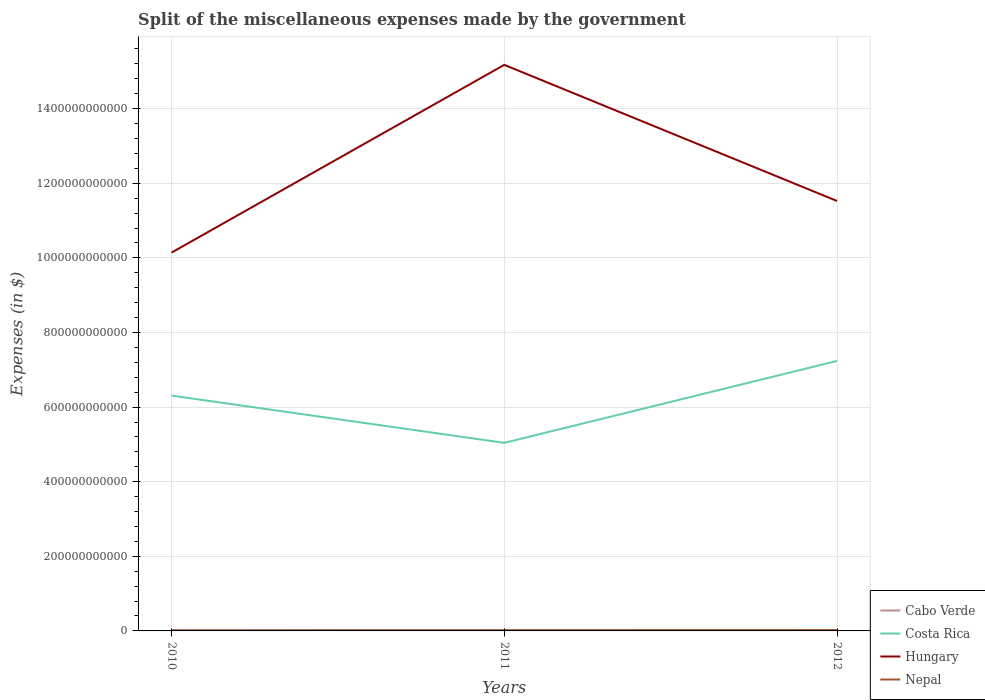Does the line corresponding to Hungary intersect with the line corresponding to Nepal?
Provide a succinct answer. No. Across all years, what is the maximum miscellaneous expenses made by the government in Nepal?
Give a very brief answer. 1.38e+09. In which year was the miscellaneous expenses made by the government in Hungary maximum?
Ensure brevity in your answer.  2010. What is the total miscellaneous expenses made by the government in Cabo Verde in the graph?
Ensure brevity in your answer.  8.47e+07. What is the difference between the highest and the second highest miscellaneous expenses made by the government in Nepal?
Offer a terse response. 6.13e+08. How many years are there in the graph?
Your answer should be very brief. 3. What is the difference between two consecutive major ticks on the Y-axis?
Keep it short and to the point. 2.00e+11. Where does the legend appear in the graph?
Offer a very short reply. Bottom right. How many legend labels are there?
Ensure brevity in your answer.  4. How are the legend labels stacked?
Your answer should be compact. Vertical. What is the title of the graph?
Your answer should be very brief. Split of the miscellaneous expenses made by the government. What is the label or title of the X-axis?
Your answer should be very brief. Years. What is the label or title of the Y-axis?
Ensure brevity in your answer.  Expenses (in $). What is the Expenses (in $) in Cabo Verde in 2010?
Make the answer very short. 1.46e+09. What is the Expenses (in $) in Costa Rica in 2010?
Your answer should be very brief. 6.31e+11. What is the Expenses (in $) in Hungary in 2010?
Your response must be concise. 1.01e+12. What is the Expenses (in $) of Nepal in 2010?
Offer a very short reply. 1.38e+09. What is the Expenses (in $) in Cabo Verde in 2011?
Offer a very short reply. 1.80e+09. What is the Expenses (in $) of Costa Rica in 2011?
Keep it short and to the point. 5.04e+11. What is the Expenses (in $) in Hungary in 2011?
Your answer should be compact. 1.52e+12. What is the Expenses (in $) of Nepal in 2011?
Your response must be concise. 1.86e+09. What is the Expenses (in $) of Cabo Verde in 2012?
Provide a succinct answer. 1.71e+09. What is the Expenses (in $) of Costa Rica in 2012?
Make the answer very short. 7.24e+11. What is the Expenses (in $) in Hungary in 2012?
Your response must be concise. 1.15e+12. What is the Expenses (in $) in Nepal in 2012?
Provide a succinct answer. 2.00e+09. Across all years, what is the maximum Expenses (in $) of Cabo Verde?
Offer a very short reply. 1.80e+09. Across all years, what is the maximum Expenses (in $) in Costa Rica?
Give a very brief answer. 7.24e+11. Across all years, what is the maximum Expenses (in $) in Hungary?
Provide a short and direct response. 1.52e+12. Across all years, what is the maximum Expenses (in $) in Nepal?
Keep it short and to the point. 2.00e+09. Across all years, what is the minimum Expenses (in $) of Cabo Verde?
Your answer should be very brief. 1.46e+09. Across all years, what is the minimum Expenses (in $) in Costa Rica?
Provide a short and direct response. 5.04e+11. Across all years, what is the minimum Expenses (in $) of Hungary?
Keep it short and to the point. 1.01e+12. Across all years, what is the minimum Expenses (in $) in Nepal?
Your response must be concise. 1.38e+09. What is the total Expenses (in $) of Cabo Verde in the graph?
Provide a succinct answer. 4.97e+09. What is the total Expenses (in $) of Costa Rica in the graph?
Your response must be concise. 1.86e+12. What is the total Expenses (in $) of Hungary in the graph?
Make the answer very short. 3.68e+12. What is the total Expenses (in $) in Nepal in the graph?
Give a very brief answer. 5.24e+09. What is the difference between the Expenses (in $) of Cabo Verde in 2010 and that in 2011?
Your response must be concise. -3.44e+08. What is the difference between the Expenses (in $) in Costa Rica in 2010 and that in 2011?
Ensure brevity in your answer.  1.27e+11. What is the difference between the Expenses (in $) of Hungary in 2010 and that in 2011?
Provide a succinct answer. -5.03e+11. What is the difference between the Expenses (in $) of Nepal in 2010 and that in 2011?
Provide a short and direct response. -4.77e+08. What is the difference between the Expenses (in $) in Cabo Verde in 2010 and that in 2012?
Your response must be concise. -2.59e+08. What is the difference between the Expenses (in $) in Costa Rica in 2010 and that in 2012?
Your answer should be very brief. -9.29e+1. What is the difference between the Expenses (in $) of Hungary in 2010 and that in 2012?
Your response must be concise. -1.38e+11. What is the difference between the Expenses (in $) in Nepal in 2010 and that in 2012?
Provide a succinct answer. -6.13e+08. What is the difference between the Expenses (in $) of Cabo Verde in 2011 and that in 2012?
Keep it short and to the point. 8.47e+07. What is the difference between the Expenses (in $) of Costa Rica in 2011 and that in 2012?
Keep it short and to the point. -2.20e+11. What is the difference between the Expenses (in $) in Hungary in 2011 and that in 2012?
Provide a short and direct response. 3.65e+11. What is the difference between the Expenses (in $) of Nepal in 2011 and that in 2012?
Your response must be concise. -1.36e+08. What is the difference between the Expenses (in $) of Cabo Verde in 2010 and the Expenses (in $) of Costa Rica in 2011?
Offer a terse response. -5.03e+11. What is the difference between the Expenses (in $) in Cabo Verde in 2010 and the Expenses (in $) in Hungary in 2011?
Provide a short and direct response. -1.52e+12. What is the difference between the Expenses (in $) in Cabo Verde in 2010 and the Expenses (in $) in Nepal in 2011?
Offer a terse response. -4.06e+08. What is the difference between the Expenses (in $) in Costa Rica in 2010 and the Expenses (in $) in Hungary in 2011?
Ensure brevity in your answer.  -8.87e+11. What is the difference between the Expenses (in $) of Costa Rica in 2010 and the Expenses (in $) of Nepal in 2011?
Offer a terse response. 6.29e+11. What is the difference between the Expenses (in $) of Hungary in 2010 and the Expenses (in $) of Nepal in 2011?
Offer a very short reply. 1.01e+12. What is the difference between the Expenses (in $) of Cabo Verde in 2010 and the Expenses (in $) of Costa Rica in 2012?
Your answer should be very brief. -7.22e+11. What is the difference between the Expenses (in $) of Cabo Verde in 2010 and the Expenses (in $) of Hungary in 2012?
Offer a terse response. -1.15e+12. What is the difference between the Expenses (in $) of Cabo Verde in 2010 and the Expenses (in $) of Nepal in 2012?
Make the answer very short. -5.41e+08. What is the difference between the Expenses (in $) of Costa Rica in 2010 and the Expenses (in $) of Hungary in 2012?
Offer a very short reply. -5.22e+11. What is the difference between the Expenses (in $) in Costa Rica in 2010 and the Expenses (in $) in Nepal in 2012?
Provide a short and direct response. 6.29e+11. What is the difference between the Expenses (in $) of Hungary in 2010 and the Expenses (in $) of Nepal in 2012?
Provide a short and direct response. 1.01e+12. What is the difference between the Expenses (in $) of Cabo Verde in 2011 and the Expenses (in $) of Costa Rica in 2012?
Keep it short and to the point. -7.22e+11. What is the difference between the Expenses (in $) of Cabo Verde in 2011 and the Expenses (in $) of Hungary in 2012?
Offer a terse response. -1.15e+12. What is the difference between the Expenses (in $) of Cabo Verde in 2011 and the Expenses (in $) of Nepal in 2012?
Your answer should be compact. -1.97e+08. What is the difference between the Expenses (in $) of Costa Rica in 2011 and the Expenses (in $) of Hungary in 2012?
Your answer should be very brief. -6.48e+11. What is the difference between the Expenses (in $) of Costa Rica in 2011 and the Expenses (in $) of Nepal in 2012?
Ensure brevity in your answer.  5.02e+11. What is the difference between the Expenses (in $) in Hungary in 2011 and the Expenses (in $) in Nepal in 2012?
Ensure brevity in your answer.  1.52e+12. What is the average Expenses (in $) of Cabo Verde per year?
Your answer should be very brief. 1.66e+09. What is the average Expenses (in $) in Costa Rica per year?
Your answer should be very brief. 6.20e+11. What is the average Expenses (in $) in Hungary per year?
Give a very brief answer. 1.23e+12. What is the average Expenses (in $) of Nepal per year?
Offer a terse response. 1.75e+09. In the year 2010, what is the difference between the Expenses (in $) in Cabo Verde and Expenses (in $) in Costa Rica?
Offer a terse response. -6.29e+11. In the year 2010, what is the difference between the Expenses (in $) of Cabo Verde and Expenses (in $) of Hungary?
Keep it short and to the point. -1.01e+12. In the year 2010, what is the difference between the Expenses (in $) of Cabo Verde and Expenses (in $) of Nepal?
Provide a short and direct response. 7.13e+07. In the year 2010, what is the difference between the Expenses (in $) in Costa Rica and Expenses (in $) in Hungary?
Make the answer very short. -3.83e+11. In the year 2010, what is the difference between the Expenses (in $) in Costa Rica and Expenses (in $) in Nepal?
Your response must be concise. 6.29e+11. In the year 2010, what is the difference between the Expenses (in $) in Hungary and Expenses (in $) in Nepal?
Ensure brevity in your answer.  1.01e+12. In the year 2011, what is the difference between the Expenses (in $) in Cabo Verde and Expenses (in $) in Costa Rica?
Make the answer very short. -5.02e+11. In the year 2011, what is the difference between the Expenses (in $) of Cabo Verde and Expenses (in $) of Hungary?
Make the answer very short. -1.52e+12. In the year 2011, what is the difference between the Expenses (in $) of Cabo Verde and Expenses (in $) of Nepal?
Provide a succinct answer. -6.16e+07. In the year 2011, what is the difference between the Expenses (in $) of Costa Rica and Expenses (in $) of Hungary?
Give a very brief answer. -1.01e+12. In the year 2011, what is the difference between the Expenses (in $) of Costa Rica and Expenses (in $) of Nepal?
Your response must be concise. 5.02e+11. In the year 2011, what is the difference between the Expenses (in $) of Hungary and Expenses (in $) of Nepal?
Ensure brevity in your answer.  1.52e+12. In the year 2012, what is the difference between the Expenses (in $) of Cabo Verde and Expenses (in $) of Costa Rica?
Ensure brevity in your answer.  -7.22e+11. In the year 2012, what is the difference between the Expenses (in $) in Cabo Verde and Expenses (in $) in Hungary?
Provide a succinct answer. -1.15e+12. In the year 2012, what is the difference between the Expenses (in $) in Cabo Verde and Expenses (in $) in Nepal?
Keep it short and to the point. -2.82e+08. In the year 2012, what is the difference between the Expenses (in $) in Costa Rica and Expenses (in $) in Hungary?
Your answer should be compact. -4.29e+11. In the year 2012, what is the difference between the Expenses (in $) in Costa Rica and Expenses (in $) in Nepal?
Provide a short and direct response. 7.22e+11. In the year 2012, what is the difference between the Expenses (in $) of Hungary and Expenses (in $) of Nepal?
Keep it short and to the point. 1.15e+12. What is the ratio of the Expenses (in $) in Cabo Verde in 2010 to that in 2011?
Offer a terse response. 0.81. What is the ratio of the Expenses (in $) of Costa Rica in 2010 to that in 2011?
Offer a very short reply. 1.25. What is the ratio of the Expenses (in $) in Hungary in 2010 to that in 2011?
Give a very brief answer. 0.67. What is the ratio of the Expenses (in $) in Nepal in 2010 to that in 2011?
Your answer should be very brief. 0.74. What is the ratio of the Expenses (in $) in Cabo Verde in 2010 to that in 2012?
Ensure brevity in your answer.  0.85. What is the ratio of the Expenses (in $) in Costa Rica in 2010 to that in 2012?
Keep it short and to the point. 0.87. What is the ratio of the Expenses (in $) in Hungary in 2010 to that in 2012?
Make the answer very short. 0.88. What is the ratio of the Expenses (in $) of Nepal in 2010 to that in 2012?
Provide a short and direct response. 0.69. What is the ratio of the Expenses (in $) in Cabo Verde in 2011 to that in 2012?
Offer a terse response. 1.05. What is the ratio of the Expenses (in $) of Costa Rica in 2011 to that in 2012?
Offer a terse response. 0.7. What is the ratio of the Expenses (in $) of Hungary in 2011 to that in 2012?
Your answer should be very brief. 1.32. What is the ratio of the Expenses (in $) of Nepal in 2011 to that in 2012?
Offer a terse response. 0.93. What is the difference between the highest and the second highest Expenses (in $) in Cabo Verde?
Offer a very short reply. 8.47e+07. What is the difference between the highest and the second highest Expenses (in $) in Costa Rica?
Your response must be concise. 9.29e+1. What is the difference between the highest and the second highest Expenses (in $) of Hungary?
Your response must be concise. 3.65e+11. What is the difference between the highest and the second highest Expenses (in $) in Nepal?
Keep it short and to the point. 1.36e+08. What is the difference between the highest and the lowest Expenses (in $) of Cabo Verde?
Keep it short and to the point. 3.44e+08. What is the difference between the highest and the lowest Expenses (in $) of Costa Rica?
Offer a terse response. 2.20e+11. What is the difference between the highest and the lowest Expenses (in $) in Hungary?
Make the answer very short. 5.03e+11. What is the difference between the highest and the lowest Expenses (in $) in Nepal?
Provide a short and direct response. 6.13e+08. 